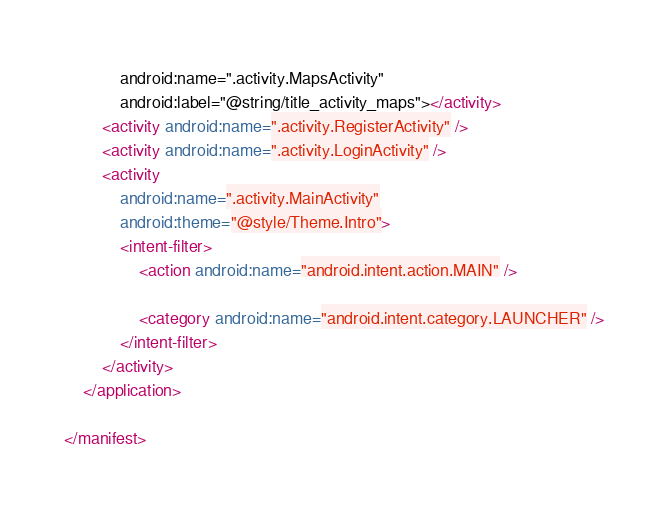<code> <loc_0><loc_0><loc_500><loc_500><_XML_>            android:name=".activity.MapsActivity"
            android:label="@string/title_activity_maps"></activity>
        <activity android:name=".activity.RegisterActivity" />
        <activity android:name=".activity.LoginActivity" />
        <activity
            android:name=".activity.MainActivity"
            android:theme="@style/Theme.Intro">
            <intent-filter>
                <action android:name="android.intent.action.MAIN" />

                <category android:name="android.intent.category.LAUNCHER" />
            </intent-filter>
        </activity>
    </application>

</manifest></code> 